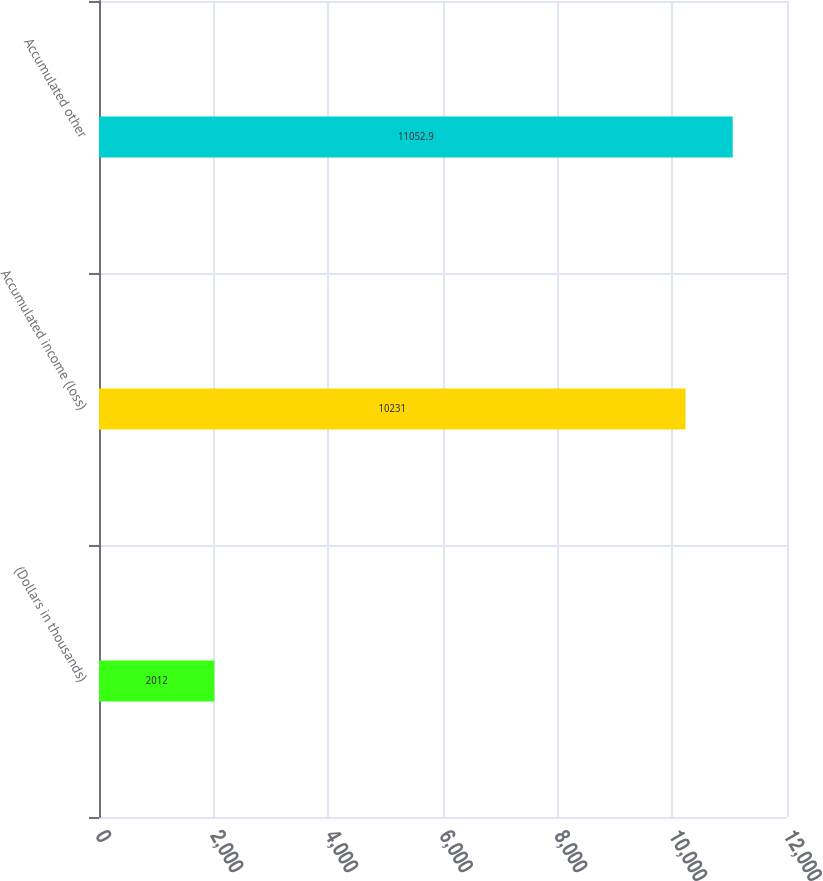Convert chart. <chart><loc_0><loc_0><loc_500><loc_500><bar_chart><fcel>(Dollars in thousands)<fcel>Accumulated income (loss)<fcel>Accumulated other<nl><fcel>2012<fcel>10231<fcel>11052.9<nl></chart> 